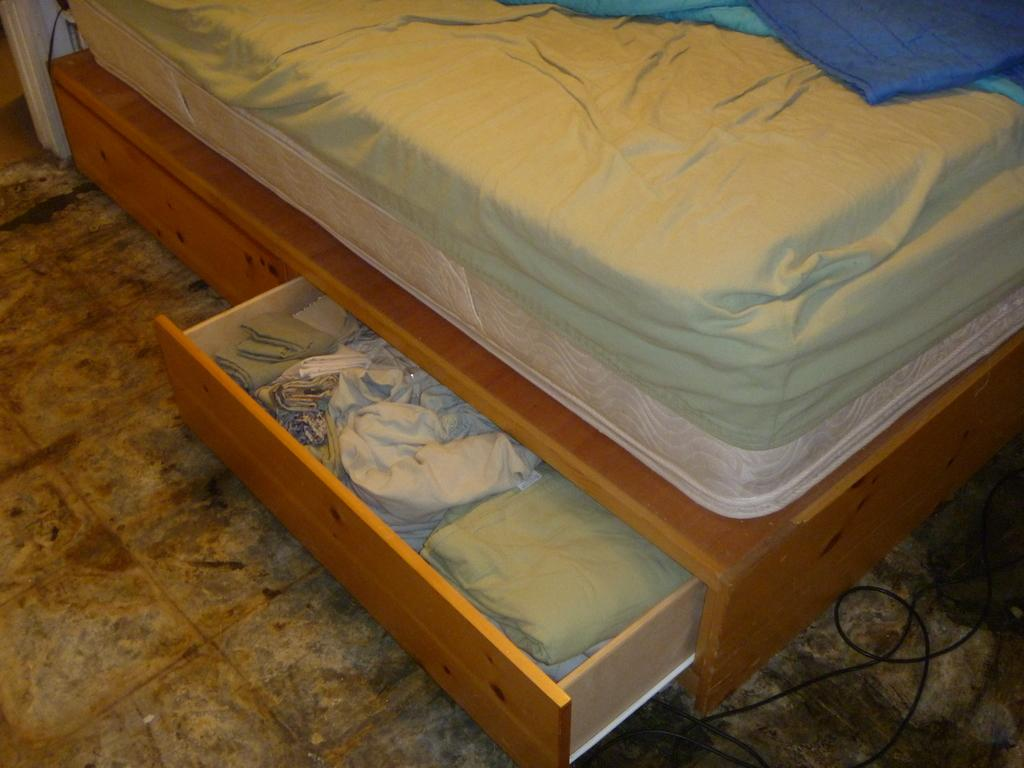What type of furniture is present in the image? There is a bed in the image. Where is the bed located in the image? The bed is located at the top side of the image. What other furniture can be seen in the image? There are cupboards in the image. Where are the cupboards positioned in relation to the bed? The cupboards are located at the bottom side of the bed. What type of lawyer is depicted holding a flag in the image? There is no lawyer or flag present in the image. Is there any indication of a wound on the bed in the image? There is no wound visible on the bed or any other part of the image. 